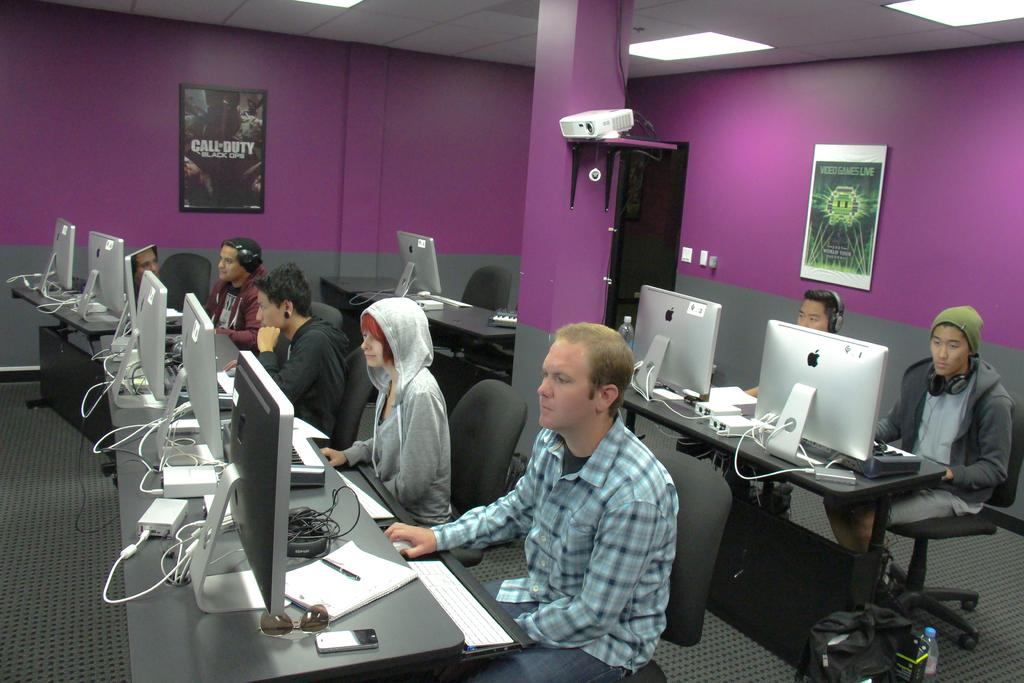<image>
Summarize the visual content of the image. A room full of people playing games, with a Call of Duty poster hanging on the wall. 